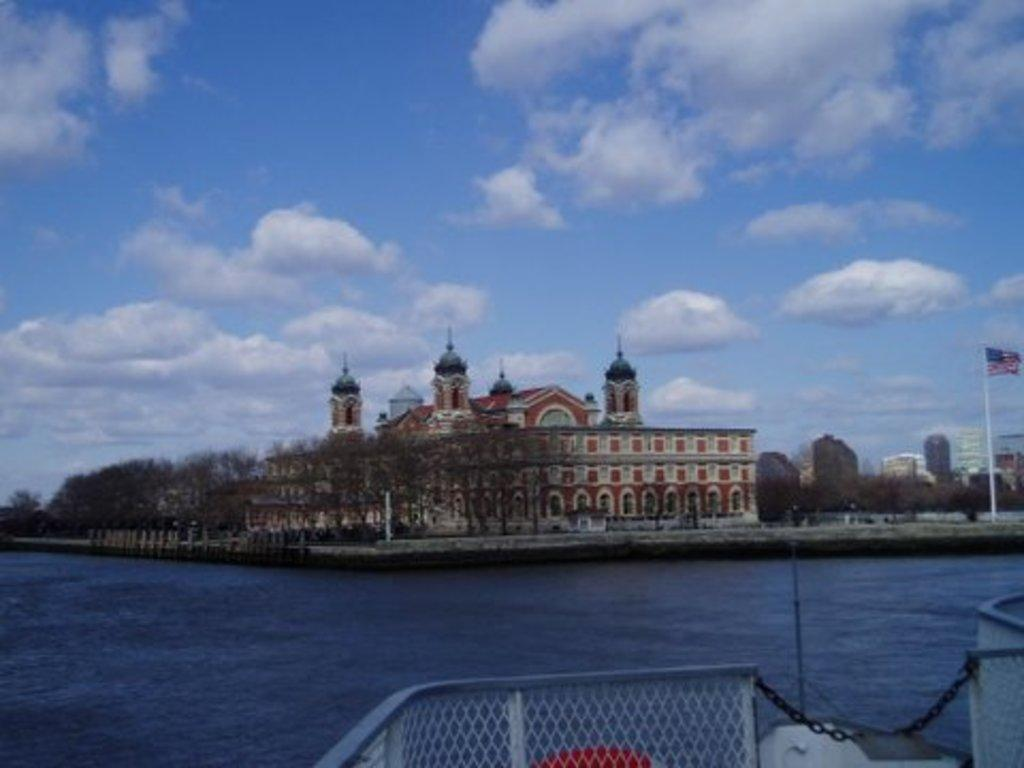What is located in the center of the image? There are trees and a building in the center of the image. What can be found at the bottom of the image? There is a deck and water visible at the bottom of the image. What is visible in the background of the image? There are buildings, the sky, and clouds visible in the background of the image. What type of mitten is being worn by the tree in the image? There are no mittens present in the image, as it features trees and a building. Can you tell me how many noses are visible on the buildings in the background? There are no noses visible on the buildings in the image; only the structures themselves are present. 